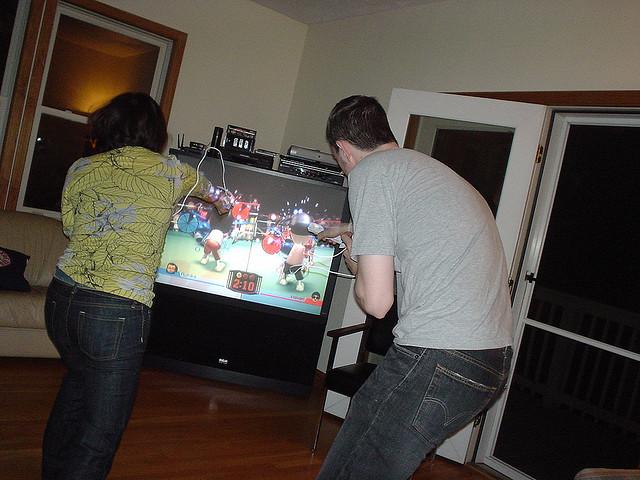What is she playing on the TV?
Short answer required. Boxing. What are they doing?
Answer briefly. Playing game. What are the women standing next to?
Answer briefly. Man. What kind of game are the people playing?
Concise answer only. Boxing. What console are the people using?
Write a very short answer. Wii. What color pants is the woman wearing?
Write a very short answer. Blue. Are they playing on a large screen television?
Quick response, please. Yes. 